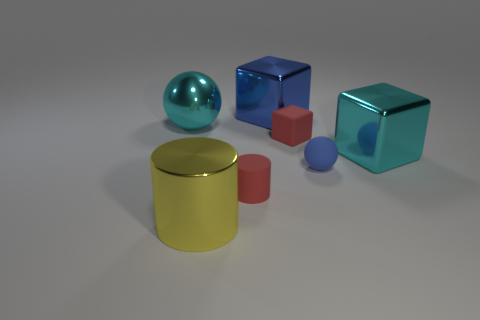How many other objects are the same material as the yellow thing?
Give a very brief answer. 3. The cyan metallic sphere is what size?
Your answer should be compact. Large. Is there a tiny blue object that has the same shape as the large yellow metal object?
Make the answer very short. No. What number of objects are either tiny yellow matte balls or big objects that are to the right of the metal sphere?
Your answer should be very brief. 3. The sphere right of the yellow metal object is what color?
Offer a terse response. Blue. There is a shiny block on the left side of the tiny blue thing; is it the same size as the sphere in front of the big cyan metal sphere?
Give a very brief answer. No. Are there any yellow objects of the same size as the blue ball?
Provide a short and direct response. No. There is a big yellow shiny cylinder that is on the left side of the large blue shiny thing; what number of small rubber balls are in front of it?
Your response must be concise. 0. What is the material of the cyan cube?
Your answer should be very brief. Metal. There is a large cyan cube; what number of shiny things are on the left side of it?
Your answer should be compact. 3. 